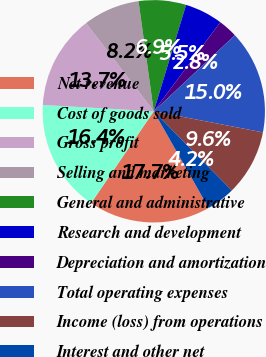Convert chart. <chart><loc_0><loc_0><loc_500><loc_500><pie_chart><fcel>Net revenue<fcel>Cost of goods sold<fcel>Gross profit<fcel>Selling and marketing<fcel>General and administrative<fcel>Research and development<fcel>Depreciation and amortization<fcel>Total operating expenses<fcel>Income (loss) from operations<fcel>Interest and other net<nl><fcel>17.74%<fcel>16.38%<fcel>13.67%<fcel>8.23%<fcel>6.88%<fcel>5.52%<fcel>2.8%<fcel>15.03%<fcel>9.59%<fcel>4.16%<nl></chart> 